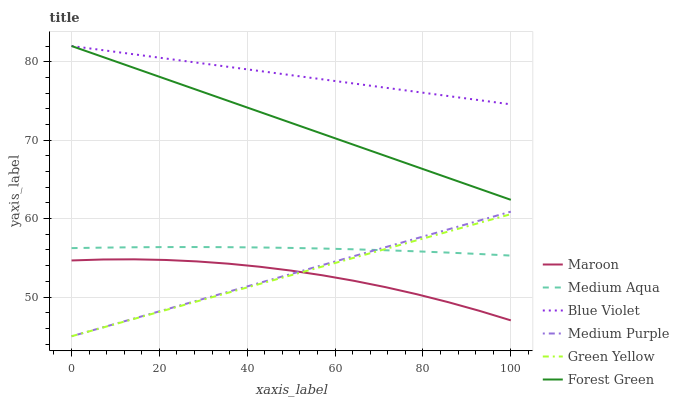Does Maroon have the minimum area under the curve?
Answer yes or no. Yes. Does Blue Violet have the maximum area under the curve?
Answer yes or no. Yes. Does Medium Purple have the minimum area under the curve?
Answer yes or no. No. Does Medium Purple have the maximum area under the curve?
Answer yes or no. No. Is Green Yellow the smoothest?
Answer yes or no. Yes. Is Maroon the roughest?
Answer yes or no. Yes. Is Medium Purple the smoothest?
Answer yes or no. No. Is Medium Purple the roughest?
Answer yes or no. No. Does Forest Green have the lowest value?
Answer yes or no. No. Does Blue Violet have the highest value?
Answer yes or no. Yes. Does Medium Purple have the highest value?
Answer yes or no. No. Is Green Yellow less than Forest Green?
Answer yes or no. Yes. Is Forest Green greater than Green Yellow?
Answer yes or no. Yes. Does Green Yellow intersect Maroon?
Answer yes or no. Yes. Is Green Yellow less than Maroon?
Answer yes or no. No. Is Green Yellow greater than Maroon?
Answer yes or no. No. Does Green Yellow intersect Forest Green?
Answer yes or no. No. 